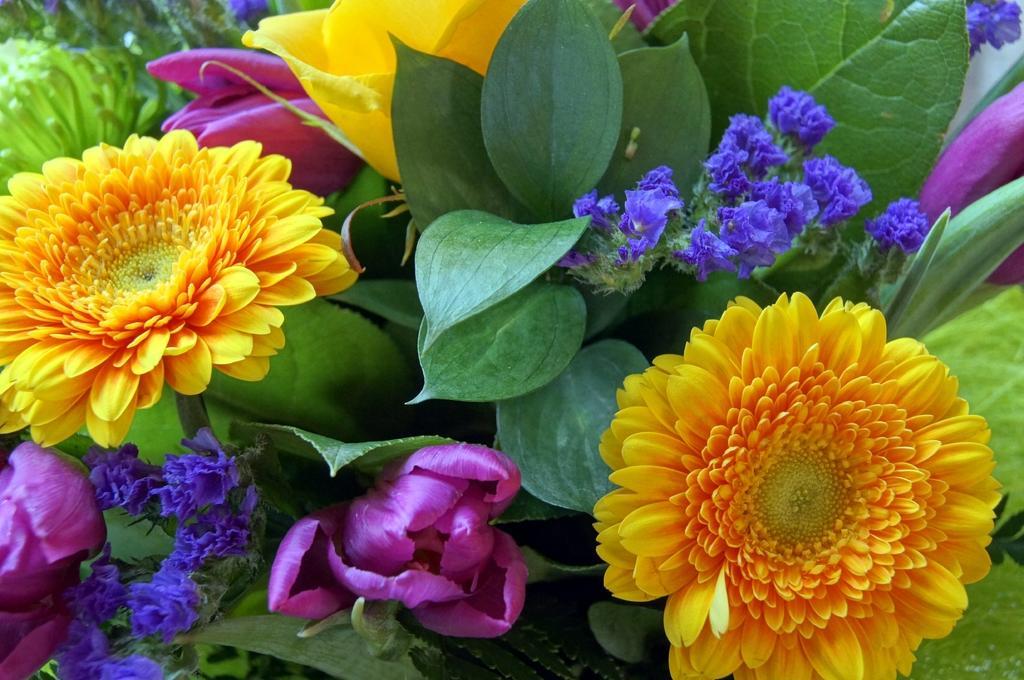Describe this image in one or two sentences. This is the picture of a plant to which there are some flowers which are in yellow, purple and blue color. 